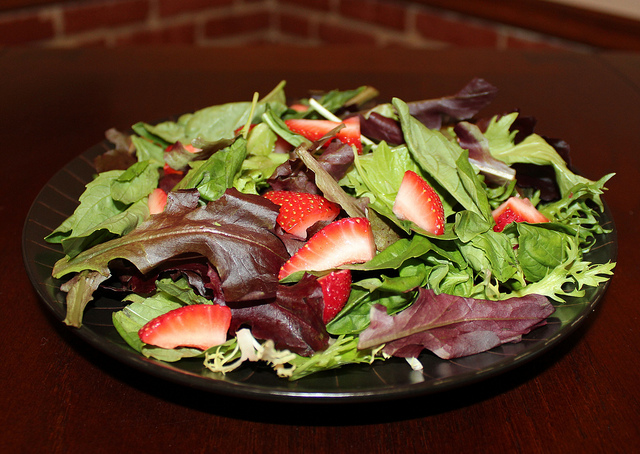<image>What orange vegetable is in the bowl? There is no orange vegetable in the bowl. What orange vegetable is in the bowl? I am not sure what orange vegetable is in the bowl. It can be seen "carrots" or "carrot". 